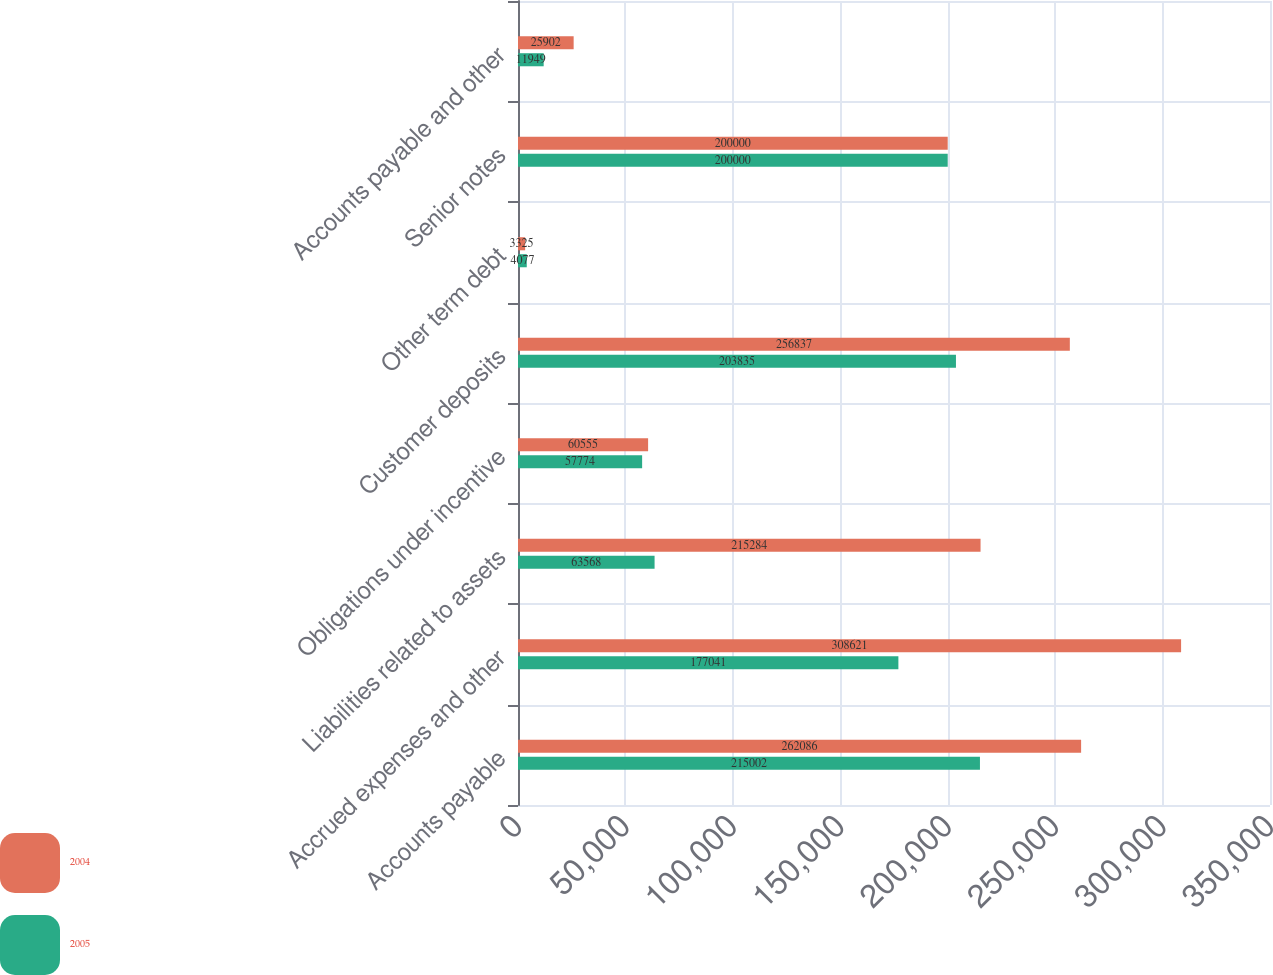Convert chart to OTSL. <chart><loc_0><loc_0><loc_500><loc_500><stacked_bar_chart><ecel><fcel>Accounts payable<fcel>Accrued expenses and other<fcel>Liabilities related to assets<fcel>Obligations under incentive<fcel>Customer deposits<fcel>Other term debt<fcel>Senior notes<fcel>Accounts payable and other<nl><fcel>2004<fcel>262086<fcel>308621<fcel>215284<fcel>60555<fcel>256837<fcel>3325<fcel>200000<fcel>25902<nl><fcel>2005<fcel>215002<fcel>177041<fcel>63568<fcel>57774<fcel>203835<fcel>4077<fcel>200000<fcel>11949<nl></chart> 